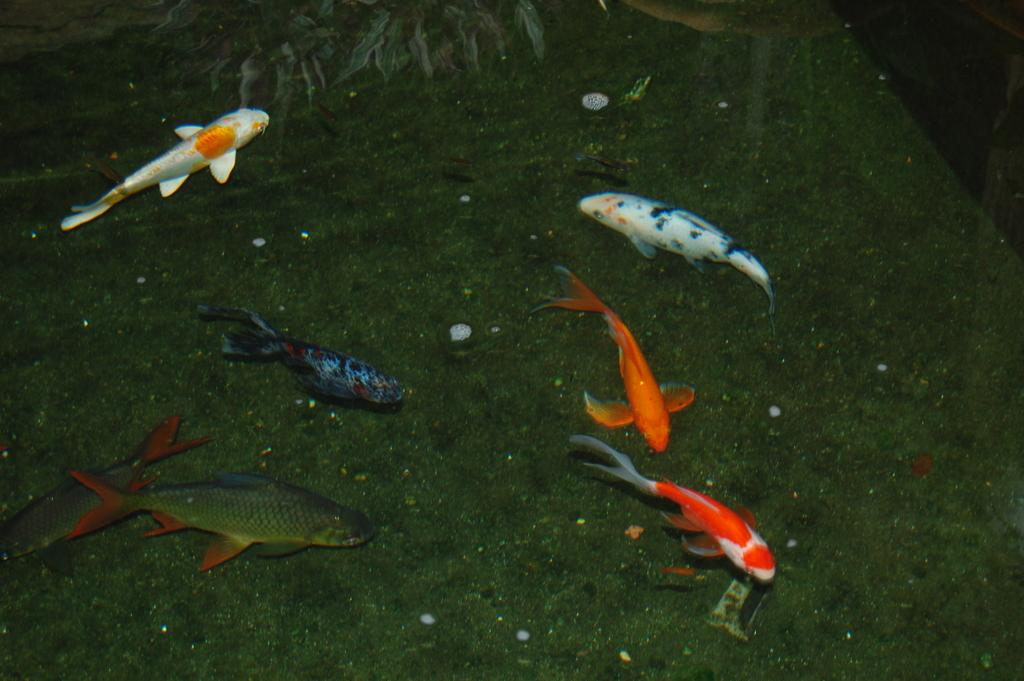What types of animals can be seen in the image? There are different kinds of fish in the image. What other living organism is present in the image? There is a plant in the image. How many servants are attending to the fish in the image? There are no servants present in the image; it features fish and a plant. What type of fruit can be seen hanging from the plant in the image? There is no fruit visible on the plant in the image. 